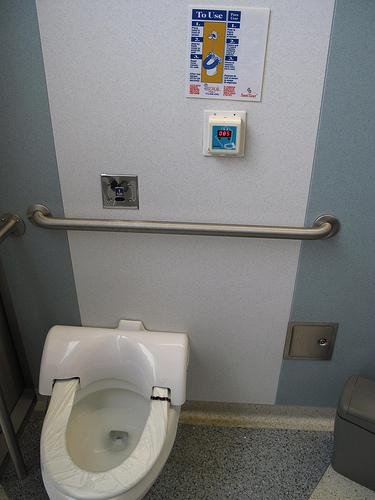Question: what above the toilet?
Choices:
A. A towel.
B. A sign.
C. A cabinet.
D. A shelf.
Answer with the letter. Answer: B Question: why is the sign in the restroom?
Choices:
A. To remind you there's no smoking.
B. To remind you to wash your hands.
C. To instruct people on toilet use.
D. To remind you not to flush sanitary napkins.
Answer with the letter. Answer: C Question: how does the bathroom look?
Choices:
A. Clean.
B. Dirty.
C. Messy.
D. Discusting.
Answer with the letter. Answer: A Question: who uses a toilet?
Choices:
A. People.
B. Toddlers.
C. Adults.
D. Teenagers.
Answer with the letter. Answer: A Question: what is the pattern of the floor?
Choices:
A. Speckled.
B. Striped.
C. Plaid.
D. Checkered.
Answer with the letter. Answer: A 